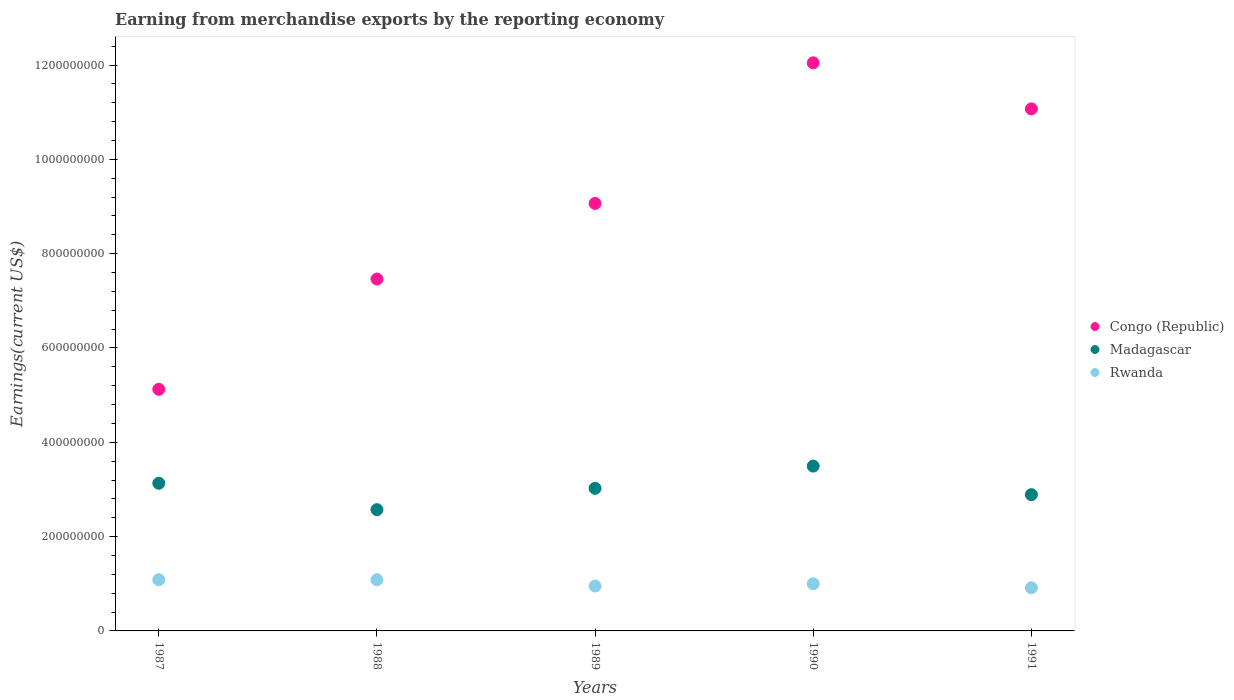How many different coloured dotlines are there?
Ensure brevity in your answer.  3. Is the number of dotlines equal to the number of legend labels?
Give a very brief answer. Yes. What is the amount earned from merchandise exports in Rwanda in 1989?
Give a very brief answer. 9.52e+07. Across all years, what is the maximum amount earned from merchandise exports in Congo (Republic)?
Your answer should be compact. 1.20e+09. Across all years, what is the minimum amount earned from merchandise exports in Rwanda?
Give a very brief answer. 9.15e+07. In which year was the amount earned from merchandise exports in Rwanda maximum?
Offer a terse response. 1987. In which year was the amount earned from merchandise exports in Madagascar minimum?
Your answer should be very brief. 1988. What is the total amount earned from merchandise exports in Congo (Republic) in the graph?
Ensure brevity in your answer.  4.48e+09. What is the difference between the amount earned from merchandise exports in Madagascar in 1987 and that in 1991?
Your answer should be very brief. 2.42e+07. What is the difference between the amount earned from merchandise exports in Congo (Republic) in 1988 and the amount earned from merchandise exports in Rwanda in 1987?
Your answer should be compact. 6.38e+08. What is the average amount earned from merchandise exports in Madagascar per year?
Your answer should be very brief. 3.02e+08. In the year 1988, what is the difference between the amount earned from merchandise exports in Rwanda and amount earned from merchandise exports in Madagascar?
Provide a succinct answer. -1.49e+08. What is the ratio of the amount earned from merchandise exports in Rwanda in 1990 to that in 1991?
Provide a short and direct response. 1.09. What is the difference between the highest and the second highest amount earned from merchandise exports in Madagascar?
Offer a very short reply. 3.64e+07. What is the difference between the highest and the lowest amount earned from merchandise exports in Madagascar?
Offer a very short reply. 9.24e+07. In how many years, is the amount earned from merchandise exports in Madagascar greater than the average amount earned from merchandise exports in Madagascar taken over all years?
Offer a terse response. 3. Is it the case that in every year, the sum of the amount earned from merchandise exports in Congo (Republic) and amount earned from merchandise exports in Madagascar  is greater than the amount earned from merchandise exports in Rwanda?
Offer a terse response. Yes. Does the amount earned from merchandise exports in Rwanda monotonically increase over the years?
Offer a very short reply. No. Are the values on the major ticks of Y-axis written in scientific E-notation?
Keep it short and to the point. No. How are the legend labels stacked?
Give a very brief answer. Vertical. What is the title of the graph?
Provide a succinct answer. Earning from merchandise exports by the reporting economy. What is the label or title of the X-axis?
Provide a succinct answer. Years. What is the label or title of the Y-axis?
Your answer should be compact. Earnings(current US$). What is the Earnings(current US$) in Congo (Republic) in 1987?
Your answer should be compact. 5.12e+08. What is the Earnings(current US$) in Madagascar in 1987?
Your answer should be compact. 3.13e+08. What is the Earnings(current US$) in Rwanda in 1987?
Keep it short and to the point. 1.09e+08. What is the Earnings(current US$) of Congo (Republic) in 1988?
Your answer should be compact. 7.46e+08. What is the Earnings(current US$) of Madagascar in 1988?
Your answer should be very brief. 2.57e+08. What is the Earnings(current US$) in Rwanda in 1988?
Keep it short and to the point. 1.09e+08. What is the Earnings(current US$) of Congo (Republic) in 1989?
Give a very brief answer. 9.07e+08. What is the Earnings(current US$) in Madagascar in 1989?
Keep it short and to the point. 3.02e+08. What is the Earnings(current US$) in Rwanda in 1989?
Your answer should be very brief. 9.52e+07. What is the Earnings(current US$) in Congo (Republic) in 1990?
Provide a succinct answer. 1.20e+09. What is the Earnings(current US$) of Madagascar in 1990?
Make the answer very short. 3.50e+08. What is the Earnings(current US$) of Rwanda in 1990?
Your answer should be compact. 9.99e+07. What is the Earnings(current US$) of Congo (Republic) in 1991?
Your answer should be very brief. 1.11e+09. What is the Earnings(current US$) of Madagascar in 1991?
Provide a succinct answer. 2.89e+08. What is the Earnings(current US$) in Rwanda in 1991?
Provide a short and direct response. 9.15e+07. Across all years, what is the maximum Earnings(current US$) in Congo (Republic)?
Your answer should be very brief. 1.20e+09. Across all years, what is the maximum Earnings(current US$) of Madagascar?
Offer a very short reply. 3.50e+08. Across all years, what is the maximum Earnings(current US$) of Rwanda?
Your response must be concise. 1.09e+08. Across all years, what is the minimum Earnings(current US$) in Congo (Republic)?
Ensure brevity in your answer.  5.12e+08. Across all years, what is the minimum Earnings(current US$) of Madagascar?
Provide a succinct answer. 2.57e+08. Across all years, what is the minimum Earnings(current US$) in Rwanda?
Offer a terse response. 9.15e+07. What is the total Earnings(current US$) of Congo (Republic) in the graph?
Your response must be concise. 4.48e+09. What is the total Earnings(current US$) of Madagascar in the graph?
Your answer should be compact. 1.51e+09. What is the total Earnings(current US$) in Rwanda in the graph?
Keep it short and to the point. 5.04e+08. What is the difference between the Earnings(current US$) in Congo (Republic) in 1987 and that in 1988?
Offer a terse response. -2.34e+08. What is the difference between the Earnings(current US$) in Madagascar in 1987 and that in 1988?
Ensure brevity in your answer.  5.60e+07. What is the difference between the Earnings(current US$) of Rwanda in 1987 and that in 1988?
Provide a succinct answer. 1.10e+05. What is the difference between the Earnings(current US$) of Congo (Republic) in 1987 and that in 1989?
Offer a very short reply. -3.94e+08. What is the difference between the Earnings(current US$) of Madagascar in 1987 and that in 1989?
Your answer should be compact. 1.08e+07. What is the difference between the Earnings(current US$) of Rwanda in 1987 and that in 1989?
Your answer should be very brief. 1.34e+07. What is the difference between the Earnings(current US$) in Congo (Republic) in 1987 and that in 1990?
Provide a succinct answer. -6.92e+08. What is the difference between the Earnings(current US$) in Madagascar in 1987 and that in 1990?
Make the answer very short. -3.64e+07. What is the difference between the Earnings(current US$) in Rwanda in 1987 and that in 1990?
Offer a terse response. 8.74e+06. What is the difference between the Earnings(current US$) of Congo (Republic) in 1987 and that in 1991?
Keep it short and to the point. -5.95e+08. What is the difference between the Earnings(current US$) in Madagascar in 1987 and that in 1991?
Ensure brevity in your answer.  2.42e+07. What is the difference between the Earnings(current US$) in Rwanda in 1987 and that in 1991?
Provide a succinct answer. 1.72e+07. What is the difference between the Earnings(current US$) of Congo (Republic) in 1988 and that in 1989?
Give a very brief answer. -1.60e+08. What is the difference between the Earnings(current US$) of Madagascar in 1988 and that in 1989?
Ensure brevity in your answer.  -4.52e+07. What is the difference between the Earnings(current US$) in Rwanda in 1988 and that in 1989?
Ensure brevity in your answer.  1.33e+07. What is the difference between the Earnings(current US$) in Congo (Republic) in 1988 and that in 1990?
Give a very brief answer. -4.59e+08. What is the difference between the Earnings(current US$) in Madagascar in 1988 and that in 1990?
Make the answer very short. -9.24e+07. What is the difference between the Earnings(current US$) in Rwanda in 1988 and that in 1990?
Provide a short and direct response. 8.63e+06. What is the difference between the Earnings(current US$) in Congo (Republic) in 1988 and that in 1991?
Your answer should be compact. -3.61e+08. What is the difference between the Earnings(current US$) in Madagascar in 1988 and that in 1991?
Your answer should be very brief. -3.18e+07. What is the difference between the Earnings(current US$) of Rwanda in 1988 and that in 1991?
Make the answer very short. 1.71e+07. What is the difference between the Earnings(current US$) in Congo (Republic) in 1989 and that in 1990?
Your response must be concise. -2.98e+08. What is the difference between the Earnings(current US$) of Madagascar in 1989 and that in 1990?
Your response must be concise. -4.72e+07. What is the difference between the Earnings(current US$) in Rwanda in 1989 and that in 1990?
Provide a short and direct response. -4.67e+06. What is the difference between the Earnings(current US$) of Congo (Republic) in 1989 and that in 1991?
Offer a very short reply. -2.01e+08. What is the difference between the Earnings(current US$) of Madagascar in 1989 and that in 1991?
Ensure brevity in your answer.  1.34e+07. What is the difference between the Earnings(current US$) in Rwanda in 1989 and that in 1991?
Your answer should be compact. 3.77e+06. What is the difference between the Earnings(current US$) in Congo (Republic) in 1990 and that in 1991?
Give a very brief answer. 9.76e+07. What is the difference between the Earnings(current US$) of Madagascar in 1990 and that in 1991?
Your answer should be compact. 6.06e+07. What is the difference between the Earnings(current US$) of Rwanda in 1990 and that in 1991?
Provide a short and direct response. 8.44e+06. What is the difference between the Earnings(current US$) of Congo (Republic) in 1987 and the Earnings(current US$) of Madagascar in 1988?
Your answer should be very brief. 2.55e+08. What is the difference between the Earnings(current US$) of Congo (Republic) in 1987 and the Earnings(current US$) of Rwanda in 1988?
Give a very brief answer. 4.04e+08. What is the difference between the Earnings(current US$) in Madagascar in 1987 and the Earnings(current US$) in Rwanda in 1988?
Your answer should be compact. 2.05e+08. What is the difference between the Earnings(current US$) of Congo (Republic) in 1987 and the Earnings(current US$) of Madagascar in 1989?
Your answer should be compact. 2.10e+08. What is the difference between the Earnings(current US$) of Congo (Republic) in 1987 and the Earnings(current US$) of Rwanda in 1989?
Ensure brevity in your answer.  4.17e+08. What is the difference between the Earnings(current US$) of Madagascar in 1987 and the Earnings(current US$) of Rwanda in 1989?
Keep it short and to the point. 2.18e+08. What is the difference between the Earnings(current US$) of Congo (Republic) in 1987 and the Earnings(current US$) of Madagascar in 1990?
Offer a very short reply. 1.63e+08. What is the difference between the Earnings(current US$) in Congo (Republic) in 1987 and the Earnings(current US$) in Rwanda in 1990?
Give a very brief answer. 4.12e+08. What is the difference between the Earnings(current US$) of Madagascar in 1987 and the Earnings(current US$) of Rwanda in 1990?
Provide a succinct answer. 2.13e+08. What is the difference between the Earnings(current US$) of Congo (Republic) in 1987 and the Earnings(current US$) of Madagascar in 1991?
Provide a short and direct response. 2.23e+08. What is the difference between the Earnings(current US$) of Congo (Republic) in 1987 and the Earnings(current US$) of Rwanda in 1991?
Provide a short and direct response. 4.21e+08. What is the difference between the Earnings(current US$) of Madagascar in 1987 and the Earnings(current US$) of Rwanda in 1991?
Ensure brevity in your answer.  2.22e+08. What is the difference between the Earnings(current US$) of Congo (Republic) in 1988 and the Earnings(current US$) of Madagascar in 1989?
Keep it short and to the point. 4.44e+08. What is the difference between the Earnings(current US$) in Congo (Republic) in 1988 and the Earnings(current US$) in Rwanda in 1989?
Ensure brevity in your answer.  6.51e+08. What is the difference between the Earnings(current US$) of Madagascar in 1988 and the Earnings(current US$) of Rwanda in 1989?
Your answer should be very brief. 1.62e+08. What is the difference between the Earnings(current US$) in Congo (Republic) in 1988 and the Earnings(current US$) in Madagascar in 1990?
Your answer should be compact. 3.97e+08. What is the difference between the Earnings(current US$) in Congo (Republic) in 1988 and the Earnings(current US$) in Rwanda in 1990?
Ensure brevity in your answer.  6.46e+08. What is the difference between the Earnings(current US$) in Madagascar in 1988 and the Earnings(current US$) in Rwanda in 1990?
Keep it short and to the point. 1.57e+08. What is the difference between the Earnings(current US$) in Congo (Republic) in 1988 and the Earnings(current US$) in Madagascar in 1991?
Make the answer very short. 4.57e+08. What is the difference between the Earnings(current US$) in Congo (Republic) in 1988 and the Earnings(current US$) in Rwanda in 1991?
Make the answer very short. 6.55e+08. What is the difference between the Earnings(current US$) in Madagascar in 1988 and the Earnings(current US$) in Rwanda in 1991?
Provide a short and direct response. 1.66e+08. What is the difference between the Earnings(current US$) of Congo (Republic) in 1989 and the Earnings(current US$) of Madagascar in 1990?
Make the answer very short. 5.57e+08. What is the difference between the Earnings(current US$) in Congo (Republic) in 1989 and the Earnings(current US$) in Rwanda in 1990?
Your answer should be very brief. 8.07e+08. What is the difference between the Earnings(current US$) of Madagascar in 1989 and the Earnings(current US$) of Rwanda in 1990?
Offer a terse response. 2.02e+08. What is the difference between the Earnings(current US$) of Congo (Republic) in 1989 and the Earnings(current US$) of Madagascar in 1991?
Offer a terse response. 6.18e+08. What is the difference between the Earnings(current US$) of Congo (Republic) in 1989 and the Earnings(current US$) of Rwanda in 1991?
Ensure brevity in your answer.  8.15e+08. What is the difference between the Earnings(current US$) of Madagascar in 1989 and the Earnings(current US$) of Rwanda in 1991?
Keep it short and to the point. 2.11e+08. What is the difference between the Earnings(current US$) of Congo (Republic) in 1990 and the Earnings(current US$) of Madagascar in 1991?
Make the answer very short. 9.16e+08. What is the difference between the Earnings(current US$) of Congo (Republic) in 1990 and the Earnings(current US$) of Rwanda in 1991?
Your answer should be compact. 1.11e+09. What is the difference between the Earnings(current US$) of Madagascar in 1990 and the Earnings(current US$) of Rwanda in 1991?
Your response must be concise. 2.58e+08. What is the average Earnings(current US$) of Congo (Republic) per year?
Your response must be concise. 8.95e+08. What is the average Earnings(current US$) in Madagascar per year?
Provide a succinct answer. 3.02e+08. What is the average Earnings(current US$) of Rwanda per year?
Offer a terse response. 1.01e+08. In the year 1987, what is the difference between the Earnings(current US$) in Congo (Republic) and Earnings(current US$) in Madagascar?
Ensure brevity in your answer.  1.99e+08. In the year 1987, what is the difference between the Earnings(current US$) in Congo (Republic) and Earnings(current US$) in Rwanda?
Your answer should be very brief. 4.04e+08. In the year 1987, what is the difference between the Earnings(current US$) of Madagascar and Earnings(current US$) of Rwanda?
Your answer should be very brief. 2.04e+08. In the year 1988, what is the difference between the Earnings(current US$) in Congo (Republic) and Earnings(current US$) in Madagascar?
Keep it short and to the point. 4.89e+08. In the year 1988, what is the difference between the Earnings(current US$) of Congo (Republic) and Earnings(current US$) of Rwanda?
Offer a very short reply. 6.38e+08. In the year 1988, what is the difference between the Earnings(current US$) in Madagascar and Earnings(current US$) in Rwanda?
Your answer should be very brief. 1.49e+08. In the year 1989, what is the difference between the Earnings(current US$) of Congo (Republic) and Earnings(current US$) of Madagascar?
Your response must be concise. 6.04e+08. In the year 1989, what is the difference between the Earnings(current US$) in Congo (Republic) and Earnings(current US$) in Rwanda?
Ensure brevity in your answer.  8.11e+08. In the year 1989, what is the difference between the Earnings(current US$) of Madagascar and Earnings(current US$) of Rwanda?
Offer a very short reply. 2.07e+08. In the year 1990, what is the difference between the Earnings(current US$) in Congo (Republic) and Earnings(current US$) in Madagascar?
Your answer should be very brief. 8.55e+08. In the year 1990, what is the difference between the Earnings(current US$) of Congo (Republic) and Earnings(current US$) of Rwanda?
Your answer should be very brief. 1.10e+09. In the year 1990, what is the difference between the Earnings(current US$) in Madagascar and Earnings(current US$) in Rwanda?
Your answer should be compact. 2.50e+08. In the year 1991, what is the difference between the Earnings(current US$) in Congo (Republic) and Earnings(current US$) in Madagascar?
Provide a succinct answer. 8.18e+08. In the year 1991, what is the difference between the Earnings(current US$) of Congo (Republic) and Earnings(current US$) of Rwanda?
Your response must be concise. 1.02e+09. In the year 1991, what is the difference between the Earnings(current US$) in Madagascar and Earnings(current US$) in Rwanda?
Provide a succinct answer. 1.98e+08. What is the ratio of the Earnings(current US$) of Congo (Republic) in 1987 to that in 1988?
Provide a succinct answer. 0.69. What is the ratio of the Earnings(current US$) in Madagascar in 1987 to that in 1988?
Ensure brevity in your answer.  1.22. What is the ratio of the Earnings(current US$) of Congo (Republic) in 1987 to that in 1989?
Keep it short and to the point. 0.57. What is the ratio of the Earnings(current US$) of Madagascar in 1987 to that in 1989?
Your answer should be very brief. 1.04. What is the ratio of the Earnings(current US$) of Rwanda in 1987 to that in 1989?
Offer a terse response. 1.14. What is the ratio of the Earnings(current US$) in Congo (Republic) in 1987 to that in 1990?
Offer a terse response. 0.43. What is the ratio of the Earnings(current US$) of Madagascar in 1987 to that in 1990?
Your answer should be very brief. 0.9. What is the ratio of the Earnings(current US$) of Rwanda in 1987 to that in 1990?
Ensure brevity in your answer.  1.09. What is the ratio of the Earnings(current US$) in Congo (Republic) in 1987 to that in 1991?
Offer a very short reply. 0.46. What is the ratio of the Earnings(current US$) of Madagascar in 1987 to that in 1991?
Provide a succinct answer. 1.08. What is the ratio of the Earnings(current US$) in Rwanda in 1987 to that in 1991?
Provide a succinct answer. 1.19. What is the ratio of the Earnings(current US$) in Congo (Republic) in 1988 to that in 1989?
Your answer should be very brief. 0.82. What is the ratio of the Earnings(current US$) in Madagascar in 1988 to that in 1989?
Give a very brief answer. 0.85. What is the ratio of the Earnings(current US$) in Rwanda in 1988 to that in 1989?
Keep it short and to the point. 1.14. What is the ratio of the Earnings(current US$) in Congo (Republic) in 1988 to that in 1990?
Your answer should be compact. 0.62. What is the ratio of the Earnings(current US$) in Madagascar in 1988 to that in 1990?
Your response must be concise. 0.74. What is the ratio of the Earnings(current US$) in Rwanda in 1988 to that in 1990?
Offer a very short reply. 1.09. What is the ratio of the Earnings(current US$) of Congo (Republic) in 1988 to that in 1991?
Your answer should be very brief. 0.67. What is the ratio of the Earnings(current US$) in Madagascar in 1988 to that in 1991?
Give a very brief answer. 0.89. What is the ratio of the Earnings(current US$) in Rwanda in 1988 to that in 1991?
Make the answer very short. 1.19. What is the ratio of the Earnings(current US$) in Congo (Republic) in 1989 to that in 1990?
Offer a terse response. 0.75. What is the ratio of the Earnings(current US$) of Madagascar in 1989 to that in 1990?
Give a very brief answer. 0.86. What is the ratio of the Earnings(current US$) of Rwanda in 1989 to that in 1990?
Ensure brevity in your answer.  0.95. What is the ratio of the Earnings(current US$) of Congo (Republic) in 1989 to that in 1991?
Offer a terse response. 0.82. What is the ratio of the Earnings(current US$) in Madagascar in 1989 to that in 1991?
Provide a succinct answer. 1.05. What is the ratio of the Earnings(current US$) in Rwanda in 1989 to that in 1991?
Your answer should be very brief. 1.04. What is the ratio of the Earnings(current US$) in Congo (Republic) in 1990 to that in 1991?
Ensure brevity in your answer.  1.09. What is the ratio of the Earnings(current US$) in Madagascar in 1990 to that in 1991?
Your response must be concise. 1.21. What is the ratio of the Earnings(current US$) in Rwanda in 1990 to that in 1991?
Keep it short and to the point. 1.09. What is the difference between the highest and the second highest Earnings(current US$) in Congo (Republic)?
Provide a short and direct response. 9.76e+07. What is the difference between the highest and the second highest Earnings(current US$) of Madagascar?
Your response must be concise. 3.64e+07. What is the difference between the highest and the second highest Earnings(current US$) of Rwanda?
Your answer should be compact. 1.10e+05. What is the difference between the highest and the lowest Earnings(current US$) in Congo (Republic)?
Your answer should be compact. 6.92e+08. What is the difference between the highest and the lowest Earnings(current US$) of Madagascar?
Ensure brevity in your answer.  9.24e+07. What is the difference between the highest and the lowest Earnings(current US$) in Rwanda?
Make the answer very short. 1.72e+07. 